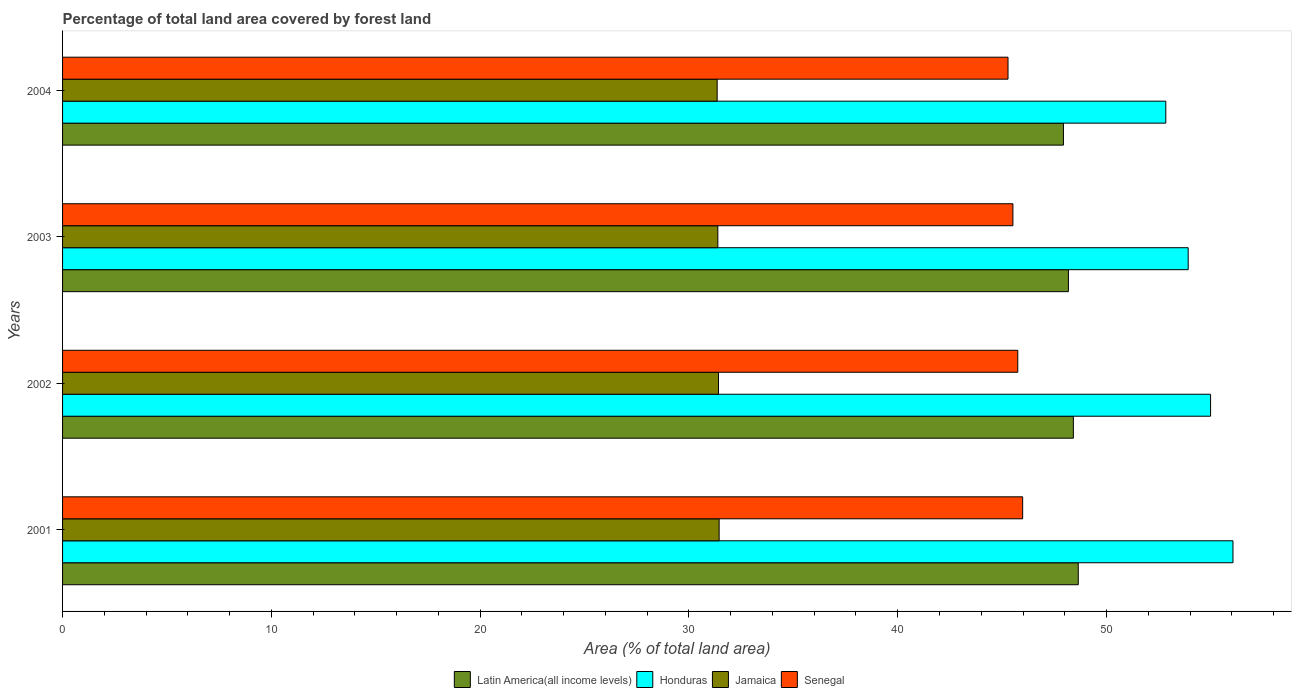How many different coloured bars are there?
Ensure brevity in your answer.  4. How many bars are there on the 3rd tick from the top?
Provide a succinct answer. 4. How many bars are there on the 3rd tick from the bottom?
Make the answer very short. 4. What is the label of the 2nd group of bars from the top?
Offer a terse response. 2003. In how many cases, is the number of bars for a given year not equal to the number of legend labels?
Your answer should be compact. 0. What is the percentage of forest land in Jamaica in 2003?
Your answer should be very brief. 31.38. Across all years, what is the maximum percentage of forest land in Jamaica?
Give a very brief answer. 31.45. Across all years, what is the minimum percentage of forest land in Jamaica?
Ensure brevity in your answer.  31.35. What is the total percentage of forest land in Jamaica in the graph?
Provide a succinct answer. 125.6. What is the difference between the percentage of forest land in Senegal in 2002 and that in 2004?
Your answer should be compact. 0.47. What is the difference between the percentage of forest land in Latin America(all income levels) in 2004 and the percentage of forest land in Jamaica in 2002?
Offer a very short reply. 16.52. What is the average percentage of forest land in Latin America(all income levels) per year?
Make the answer very short. 48.29. In the year 2001, what is the difference between the percentage of forest land in Jamaica and percentage of forest land in Honduras?
Provide a short and direct response. -24.61. What is the ratio of the percentage of forest land in Honduras in 2001 to that in 2002?
Your answer should be very brief. 1.02. Is the percentage of forest land in Jamaica in 2003 less than that in 2004?
Make the answer very short. No. What is the difference between the highest and the second highest percentage of forest land in Honduras?
Keep it short and to the point. 1.07. What is the difference between the highest and the lowest percentage of forest land in Senegal?
Ensure brevity in your answer.  0.7. Is it the case that in every year, the sum of the percentage of forest land in Senegal and percentage of forest land in Honduras is greater than the sum of percentage of forest land in Latin America(all income levels) and percentage of forest land in Jamaica?
Ensure brevity in your answer.  No. What does the 1st bar from the top in 2004 represents?
Offer a very short reply. Senegal. What does the 2nd bar from the bottom in 2003 represents?
Your response must be concise. Honduras. Is it the case that in every year, the sum of the percentage of forest land in Senegal and percentage of forest land in Honduras is greater than the percentage of forest land in Latin America(all income levels)?
Ensure brevity in your answer.  Yes. Are all the bars in the graph horizontal?
Make the answer very short. Yes. Are the values on the major ticks of X-axis written in scientific E-notation?
Offer a terse response. No. Does the graph contain grids?
Ensure brevity in your answer.  No. What is the title of the graph?
Ensure brevity in your answer.  Percentage of total land area covered by forest land. What is the label or title of the X-axis?
Offer a very short reply. Area (% of total land area). What is the label or title of the Y-axis?
Your answer should be very brief. Years. What is the Area (% of total land area) of Latin America(all income levels) in 2001?
Make the answer very short. 48.65. What is the Area (% of total land area) in Honduras in 2001?
Your answer should be compact. 56.06. What is the Area (% of total land area) in Jamaica in 2001?
Ensure brevity in your answer.  31.45. What is the Area (% of total land area) of Senegal in 2001?
Your response must be concise. 45.98. What is the Area (% of total land area) in Latin America(all income levels) in 2002?
Offer a terse response. 48.41. What is the Area (% of total land area) of Honduras in 2002?
Make the answer very short. 54.98. What is the Area (% of total land area) of Jamaica in 2002?
Offer a very short reply. 31.41. What is the Area (% of total land area) of Senegal in 2002?
Keep it short and to the point. 45.75. What is the Area (% of total land area) of Latin America(all income levels) in 2003?
Your response must be concise. 48.17. What is the Area (% of total land area) of Honduras in 2003?
Offer a terse response. 53.91. What is the Area (% of total land area) of Jamaica in 2003?
Your answer should be compact. 31.38. What is the Area (% of total land area) in Senegal in 2003?
Ensure brevity in your answer.  45.51. What is the Area (% of total land area) in Latin America(all income levels) in 2004?
Your response must be concise. 47.94. What is the Area (% of total land area) of Honduras in 2004?
Ensure brevity in your answer.  52.84. What is the Area (% of total land area) in Jamaica in 2004?
Offer a terse response. 31.35. What is the Area (% of total land area) in Senegal in 2004?
Provide a short and direct response. 45.28. Across all years, what is the maximum Area (% of total land area) in Latin America(all income levels)?
Provide a short and direct response. 48.65. Across all years, what is the maximum Area (% of total land area) in Honduras?
Make the answer very short. 56.06. Across all years, what is the maximum Area (% of total land area) in Jamaica?
Keep it short and to the point. 31.45. Across all years, what is the maximum Area (% of total land area) of Senegal?
Offer a very short reply. 45.98. Across all years, what is the minimum Area (% of total land area) of Latin America(all income levels)?
Ensure brevity in your answer.  47.94. Across all years, what is the minimum Area (% of total land area) of Honduras?
Give a very brief answer. 52.84. Across all years, what is the minimum Area (% of total land area) of Jamaica?
Your answer should be compact. 31.35. Across all years, what is the minimum Area (% of total land area) of Senegal?
Ensure brevity in your answer.  45.28. What is the total Area (% of total land area) in Latin America(all income levels) in the graph?
Your answer should be very brief. 193.16. What is the total Area (% of total land area) of Honduras in the graph?
Offer a very short reply. 217.79. What is the total Area (% of total land area) of Jamaica in the graph?
Keep it short and to the point. 125.6. What is the total Area (% of total land area) of Senegal in the graph?
Offer a terse response. 182.53. What is the difference between the Area (% of total land area) of Latin America(all income levels) in 2001 and that in 2002?
Ensure brevity in your answer.  0.23. What is the difference between the Area (% of total land area) in Honduras in 2001 and that in 2002?
Provide a succinct answer. 1.07. What is the difference between the Area (% of total land area) in Jamaica in 2001 and that in 2002?
Your response must be concise. 0.03. What is the difference between the Area (% of total land area) of Senegal in 2001 and that in 2002?
Your response must be concise. 0.23. What is the difference between the Area (% of total land area) in Latin America(all income levels) in 2001 and that in 2003?
Offer a terse response. 0.47. What is the difference between the Area (% of total land area) in Honduras in 2001 and that in 2003?
Provide a short and direct response. 2.15. What is the difference between the Area (% of total land area) in Jamaica in 2001 and that in 2003?
Keep it short and to the point. 0.06. What is the difference between the Area (% of total land area) of Senegal in 2001 and that in 2003?
Keep it short and to the point. 0.47. What is the difference between the Area (% of total land area) of Latin America(all income levels) in 2001 and that in 2004?
Offer a terse response. 0.71. What is the difference between the Area (% of total land area) of Honduras in 2001 and that in 2004?
Your answer should be compact. 3.22. What is the difference between the Area (% of total land area) in Jamaica in 2001 and that in 2004?
Your answer should be compact. 0.09. What is the difference between the Area (% of total land area) of Senegal in 2001 and that in 2004?
Your response must be concise. 0.7. What is the difference between the Area (% of total land area) in Latin America(all income levels) in 2002 and that in 2003?
Keep it short and to the point. 0.24. What is the difference between the Area (% of total land area) of Honduras in 2002 and that in 2003?
Give a very brief answer. 1.07. What is the difference between the Area (% of total land area) in Jamaica in 2002 and that in 2003?
Your response must be concise. 0.03. What is the difference between the Area (% of total land area) of Senegal in 2002 and that in 2003?
Your answer should be very brief. 0.23. What is the difference between the Area (% of total land area) in Latin America(all income levels) in 2002 and that in 2004?
Keep it short and to the point. 0.47. What is the difference between the Area (% of total land area) of Honduras in 2002 and that in 2004?
Offer a terse response. 2.15. What is the difference between the Area (% of total land area) of Jamaica in 2002 and that in 2004?
Provide a short and direct response. 0.06. What is the difference between the Area (% of total land area) in Senegal in 2002 and that in 2004?
Your response must be concise. 0.47. What is the difference between the Area (% of total land area) of Latin America(all income levels) in 2003 and that in 2004?
Make the answer very short. 0.24. What is the difference between the Area (% of total land area) of Honduras in 2003 and that in 2004?
Ensure brevity in your answer.  1.07. What is the difference between the Area (% of total land area) in Jamaica in 2003 and that in 2004?
Offer a very short reply. 0.03. What is the difference between the Area (% of total land area) of Senegal in 2003 and that in 2004?
Your response must be concise. 0.23. What is the difference between the Area (% of total land area) of Latin America(all income levels) in 2001 and the Area (% of total land area) of Honduras in 2002?
Make the answer very short. -6.34. What is the difference between the Area (% of total land area) in Latin America(all income levels) in 2001 and the Area (% of total land area) in Jamaica in 2002?
Your answer should be very brief. 17.23. What is the difference between the Area (% of total land area) in Latin America(all income levels) in 2001 and the Area (% of total land area) in Senegal in 2002?
Provide a succinct answer. 2.9. What is the difference between the Area (% of total land area) in Honduras in 2001 and the Area (% of total land area) in Jamaica in 2002?
Provide a succinct answer. 24.64. What is the difference between the Area (% of total land area) of Honduras in 2001 and the Area (% of total land area) of Senegal in 2002?
Your response must be concise. 10.31. What is the difference between the Area (% of total land area) of Jamaica in 2001 and the Area (% of total land area) of Senegal in 2002?
Give a very brief answer. -14.3. What is the difference between the Area (% of total land area) of Latin America(all income levels) in 2001 and the Area (% of total land area) of Honduras in 2003?
Offer a very short reply. -5.26. What is the difference between the Area (% of total land area) of Latin America(all income levels) in 2001 and the Area (% of total land area) of Jamaica in 2003?
Give a very brief answer. 17.26. What is the difference between the Area (% of total land area) in Latin America(all income levels) in 2001 and the Area (% of total land area) in Senegal in 2003?
Offer a terse response. 3.13. What is the difference between the Area (% of total land area) in Honduras in 2001 and the Area (% of total land area) in Jamaica in 2003?
Offer a very short reply. 24.67. What is the difference between the Area (% of total land area) of Honduras in 2001 and the Area (% of total land area) of Senegal in 2003?
Your answer should be compact. 10.54. What is the difference between the Area (% of total land area) in Jamaica in 2001 and the Area (% of total land area) in Senegal in 2003?
Your answer should be compact. -14.07. What is the difference between the Area (% of total land area) of Latin America(all income levels) in 2001 and the Area (% of total land area) of Honduras in 2004?
Give a very brief answer. -4.19. What is the difference between the Area (% of total land area) in Latin America(all income levels) in 2001 and the Area (% of total land area) in Jamaica in 2004?
Your answer should be very brief. 17.29. What is the difference between the Area (% of total land area) of Latin America(all income levels) in 2001 and the Area (% of total land area) of Senegal in 2004?
Your answer should be very brief. 3.36. What is the difference between the Area (% of total land area) of Honduras in 2001 and the Area (% of total land area) of Jamaica in 2004?
Keep it short and to the point. 24.7. What is the difference between the Area (% of total land area) in Honduras in 2001 and the Area (% of total land area) in Senegal in 2004?
Offer a terse response. 10.77. What is the difference between the Area (% of total land area) in Jamaica in 2001 and the Area (% of total land area) in Senegal in 2004?
Offer a very short reply. -13.84. What is the difference between the Area (% of total land area) of Latin America(all income levels) in 2002 and the Area (% of total land area) of Honduras in 2003?
Make the answer very short. -5.5. What is the difference between the Area (% of total land area) in Latin America(all income levels) in 2002 and the Area (% of total land area) in Jamaica in 2003?
Provide a short and direct response. 17.03. What is the difference between the Area (% of total land area) in Latin America(all income levels) in 2002 and the Area (% of total land area) in Senegal in 2003?
Your answer should be compact. 2.9. What is the difference between the Area (% of total land area) of Honduras in 2002 and the Area (% of total land area) of Jamaica in 2003?
Make the answer very short. 23.6. What is the difference between the Area (% of total land area) of Honduras in 2002 and the Area (% of total land area) of Senegal in 2003?
Provide a succinct answer. 9.47. What is the difference between the Area (% of total land area) in Jamaica in 2002 and the Area (% of total land area) in Senegal in 2003?
Make the answer very short. -14.1. What is the difference between the Area (% of total land area) in Latin America(all income levels) in 2002 and the Area (% of total land area) in Honduras in 2004?
Offer a very short reply. -4.43. What is the difference between the Area (% of total land area) in Latin America(all income levels) in 2002 and the Area (% of total land area) in Jamaica in 2004?
Make the answer very short. 17.06. What is the difference between the Area (% of total land area) of Latin America(all income levels) in 2002 and the Area (% of total land area) of Senegal in 2004?
Give a very brief answer. 3.13. What is the difference between the Area (% of total land area) of Honduras in 2002 and the Area (% of total land area) of Jamaica in 2004?
Make the answer very short. 23.63. What is the difference between the Area (% of total land area) of Honduras in 2002 and the Area (% of total land area) of Senegal in 2004?
Offer a terse response. 9.7. What is the difference between the Area (% of total land area) of Jamaica in 2002 and the Area (% of total land area) of Senegal in 2004?
Provide a short and direct response. -13.87. What is the difference between the Area (% of total land area) in Latin America(all income levels) in 2003 and the Area (% of total land area) in Honduras in 2004?
Offer a very short reply. -4.66. What is the difference between the Area (% of total land area) of Latin America(all income levels) in 2003 and the Area (% of total land area) of Jamaica in 2004?
Make the answer very short. 16.82. What is the difference between the Area (% of total land area) of Latin America(all income levels) in 2003 and the Area (% of total land area) of Senegal in 2004?
Ensure brevity in your answer.  2.89. What is the difference between the Area (% of total land area) of Honduras in 2003 and the Area (% of total land area) of Jamaica in 2004?
Your answer should be very brief. 22.56. What is the difference between the Area (% of total land area) of Honduras in 2003 and the Area (% of total land area) of Senegal in 2004?
Your response must be concise. 8.63. What is the difference between the Area (% of total land area) in Jamaica in 2003 and the Area (% of total land area) in Senegal in 2004?
Ensure brevity in your answer.  -13.9. What is the average Area (% of total land area) in Latin America(all income levels) per year?
Offer a very short reply. 48.29. What is the average Area (% of total land area) of Honduras per year?
Your response must be concise. 54.45. What is the average Area (% of total land area) of Jamaica per year?
Give a very brief answer. 31.4. What is the average Area (% of total land area) in Senegal per year?
Give a very brief answer. 45.63. In the year 2001, what is the difference between the Area (% of total land area) of Latin America(all income levels) and Area (% of total land area) of Honduras?
Give a very brief answer. -7.41. In the year 2001, what is the difference between the Area (% of total land area) in Latin America(all income levels) and Area (% of total land area) in Jamaica?
Your answer should be very brief. 17.2. In the year 2001, what is the difference between the Area (% of total land area) of Latin America(all income levels) and Area (% of total land area) of Senegal?
Your answer should be compact. 2.66. In the year 2001, what is the difference between the Area (% of total land area) in Honduras and Area (% of total land area) in Jamaica?
Provide a short and direct response. 24.61. In the year 2001, what is the difference between the Area (% of total land area) of Honduras and Area (% of total land area) of Senegal?
Your response must be concise. 10.07. In the year 2001, what is the difference between the Area (% of total land area) of Jamaica and Area (% of total land area) of Senegal?
Provide a short and direct response. -14.54. In the year 2002, what is the difference between the Area (% of total land area) of Latin America(all income levels) and Area (% of total land area) of Honduras?
Your answer should be very brief. -6.57. In the year 2002, what is the difference between the Area (% of total land area) in Latin America(all income levels) and Area (% of total land area) in Jamaica?
Your answer should be very brief. 17. In the year 2002, what is the difference between the Area (% of total land area) in Latin America(all income levels) and Area (% of total land area) in Senegal?
Provide a succinct answer. 2.66. In the year 2002, what is the difference between the Area (% of total land area) in Honduras and Area (% of total land area) in Jamaica?
Your answer should be very brief. 23.57. In the year 2002, what is the difference between the Area (% of total land area) in Honduras and Area (% of total land area) in Senegal?
Your answer should be very brief. 9.23. In the year 2002, what is the difference between the Area (% of total land area) of Jamaica and Area (% of total land area) of Senegal?
Offer a terse response. -14.33. In the year 2003, what is the difference between the Area (% of total land area) of Latin America(all income levels) and Area (% of total land area) of Honduras?
Give a very brief answer. -5.74. In the year 2003, what is the difference between the Area (% of total land area) of Latin America(all income levels) and Area (% of total land area) of Jamaica?
Make the answer very short. 16.79. In the year 2003, what is the difference between the Area (% of total land area) of Latin America(all income levels) and Area (% of total land area) of Senegal?
Keep it short and to the point. 2.66. In the year 2003, what is the difference between the Area (% of total land area) of Honduras and Area (% of total land area) of Jamaica?
Give a very brief answer. 22.53. In the year 2003, what is the difference between the Area (% of total land area) of Honduras and Area (% of total land area) of Senegal?
Your answer should be very brief. 8.4. In the year 2003, what is the difference between the Area (% of total land area) in Jamaica and Area (% of total land area) in Senegal?
Provide a succinct answer. -14.13. In the year 2004, what is the difference between the Area (% of total land area) of Latin America(all income levels) and Area (% of total land area) of Honduras?
Your answer should be very brief. -4.9. In the year 2004, what is the difference between the Area (% of total land area) in Latin America(all income levels) and Area (% of total land area) in Jamaica?
Make the answer very short. 16.58. In the year 2004, what is the difference between the Area (% of total land area) in Latin America(all income levels) and Area (% of total land area) in Senegal?
Provide a succinct answer. 2.65. In the year 2004, what is the difference between the Area (% of total land area) in Honduras and Area (% of total land area) in Jamaica?
Provide a succinct answer. 21.49. In the year 2004, what is the difference between the Area (% of total land area) in Honduras and Area (% of total land area) in Senegal?
Your answer should be compact. 7.56. In the year 2004, what is the difference between the Area (% of total land area) in Jamaica and Area (% of total land area) in Senegal?
Your answer should be very brief. -13.93. What is the ratio of the Area (% of total land area) in Latin America(all income levels) in 2001 to that in 2002?
Offer a terse response. 1. What is the ratio of the Area (% of total land area) of Honduras in 2001 to that in 2002?
Offer a very short reply. 1.02. What is the ratio of the Area (% of total land area) of Latin America(all income levels) in 2001 to that in 2003?
Keep it short and to the point. 1.01. What is the ratio of the Area (% of total land area) in Honduras in 2001 to that in 2003?
Provide a succinct answer. 1.04. What is the ratio of the Area (% of total land area) in Jamaica in 2001 to that in 2003?
Your answer should be very brief. 1. What is the ratio of the Area (% of total land area) of Senegal in 2001 to that in 2003?
Your answer should be very brief. 1.01. What is the ratio of the Area (% of total land area) of Latin America(all income levels) in 2001 to that in 2004?
Ensure brevity in your answer.  1.01. What is the ratio of the Area (% of total land area) in Honduras in 2001 to that in 2004?
Make the answer very short. 1.06. What is the ratio of the Area (% of total land area) in Jamaica in 2001 to that in 2004?
Offer a terse response. 1. What is the ratio of the Area (% of total land area) in Senegal in 2001 to that in 2004?
Make the answer very short. 1.02. What is the ratio of the Area (% of total land area) in Honduras in 2002 to that in 2003?
Give a very brief answer. 1.02. What is the ratio of the Area (% of total land area) of Jamaica in 2002 to that in 2003?
Offer a very short reply. 1. What is the ratio of the Area (% of total land area) in Latin America(all income levels) in 2002 to that in 2004?
Your response must be concise. 1.01. What is the ratio of the Area (% of total land area) of Honduras in 2002 to that in 2004?
Ensure brevity in your answer.  1.04. What is the ratio of the Area (% of total land area) in Jamaica in 2002 to that in 2004?
Give a very brief answer. 1. What is the ratio of the Area (% of total land area) in Senegal in 2002 to that in 2004?
Make the answer very short. 1.01. What is the ratio of the Area (% of total land area) of Latin America(all income levels) in 2003 to that in 2004?
Provide a short and direct response. 1. What is the ratio of the Area (% of total land area) in Honduras in 2003 to that in 2004?
Give a very brief answer. 1.02. What is the difference between the highest and the second highest Area (% of total land area) of Latin America(all income levels)?
Offer a very short reply. 0.23. What is the difference between the highest and the second highest Area (% of total land area) of Honduras?
Offer a very short reply. 1.07. What is the difference between the highest and the second highest Area (% of total land area) in Jamaica?
Give a very brief answer. 0.03. What is the difference between the highest and the second highest Area (% of total land area) in Senegal?
Your answer should be very brief. 0.23. What is the difference between the highest and the lowest Area (% of total land area) in Latin America(all income levels)?
Your answer should be very brief. 0.71. What is the difference between the highest and the lowest Area (% of total land area) of Honduras?
Provide a short and direct response. 3.22. What is the difference between the highest and the lowest Area (% of total land area) of Jamaica?
Provide a short and direct response. 0.09. What is the difference between the highest and the lowest Area (% of total land area) of Senegal?
Your response must be concise. 0.7. 